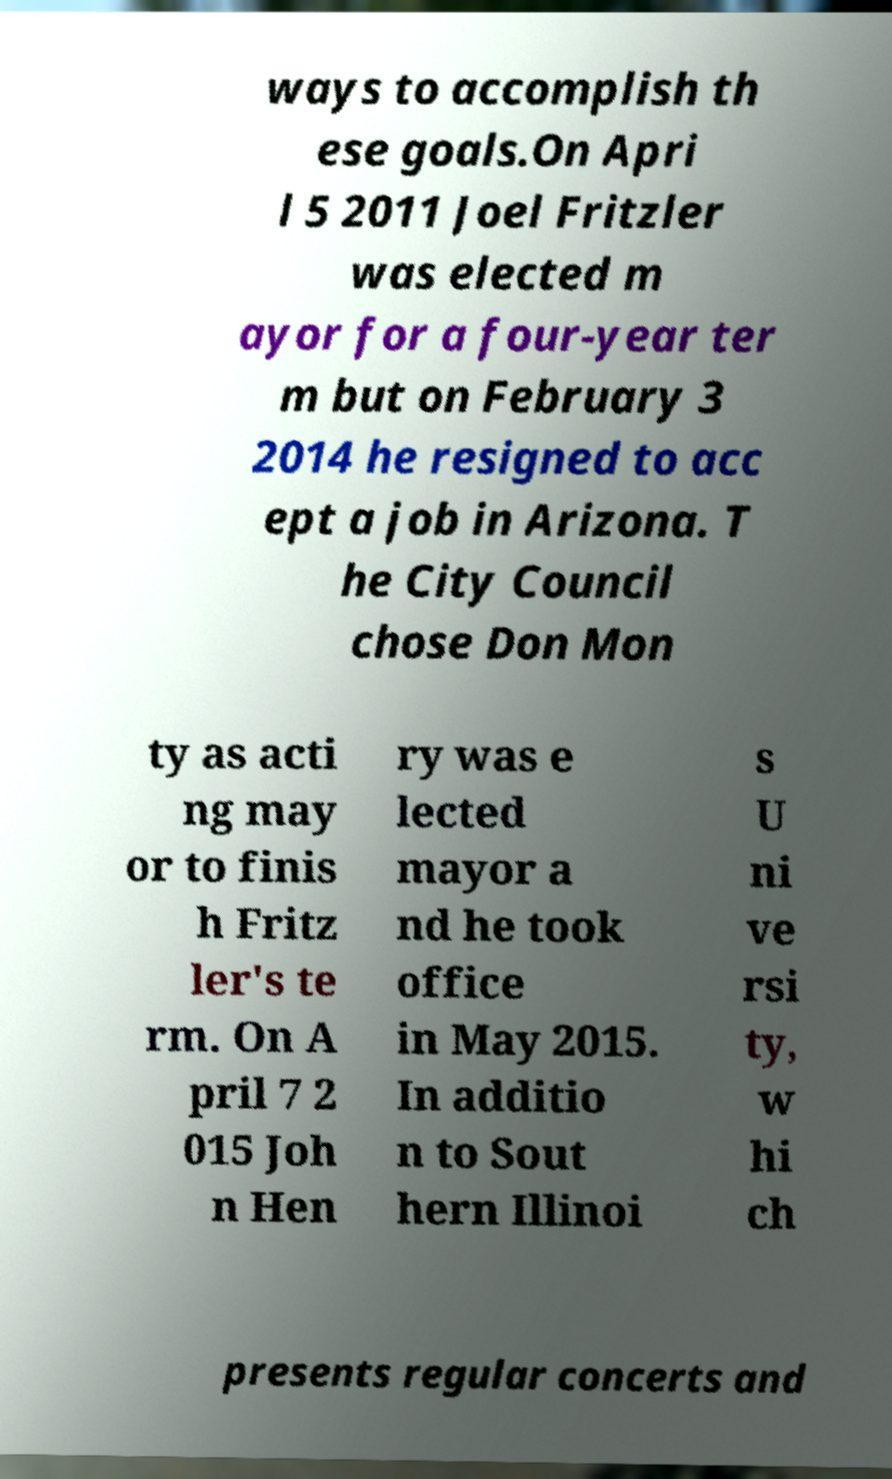For documentation purposes, I need the text within this image transcribed. Could you provide that? ways to accomplish th ese goals.On Apri l 5 2011 Joel Fritzler was elected m ayor for a four-year ter m but on February 3 2014 he resigned to acc ept a job in Arizona. T he City Council chose Don Mon ty as acti ng may or to finis h Fritz ler's te rm. On A pril 7 2 015 Joh n Hen ry was e lected mayor a nd he took office in May 2015. In additio n to Sout hern Illinoi s U ni ve rsi ty, w hi ch presents regular concerts and 